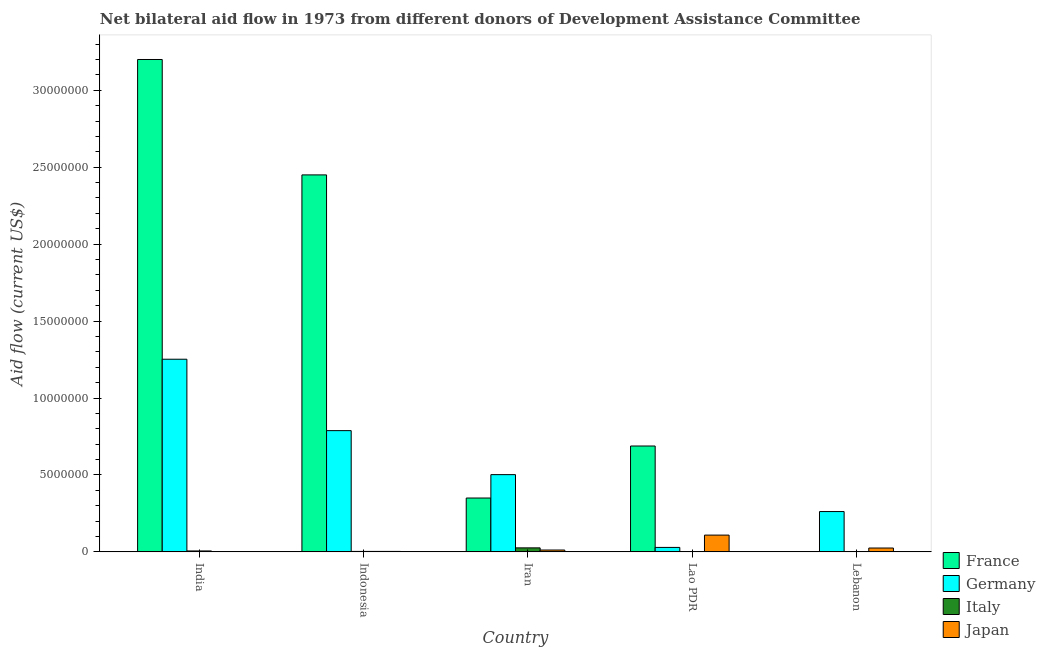Are the number of bars per tick equal to the number of legend labels?
Your response must be concise. No. How many bars are there on the 5th tick from the left?
Your answer should be compact. 3. What is the label of the 3rd group of bars from the left?
Provide a short and direct response. Iran. What is the amount of aid given by japan in Lao PDR?
Provide a short and direct response. 1.09e+06. Across all countries, what is the maximum amount of aid given by japan?
Your response must be concise. 1.09e+06. Across all countries, what is the minimum amount of aid given by italy?
Offer a very short reply. 10000. In which country was the amount of aid given by france maximum?
Your answer should be compact. India. What is the total amount of aid given by germany in the graph?
Your answer should be very brief. 2.83e+07. What is the difference between the amount of aid given by france in Iran and that in Lao PDR?
Your answer should be compact. -3.38e+06. What is the difference between the amount of aid given by germany in Lao PDR and the amount of aid given by japan in India?
Give a very brief answer. 2.80e+05. What is the difference between the amount of aid given by germany and amount of aid given by italy in India?
Keep it short and to the point. 1.25e+07. In how many countries, is the amount of aid given by japan greater than 5000000 US$?
Ensure brevity in your answer.  0. What is the ratio of the amount of aid given by germany in India to that in Iran?
Your response must be concise. 2.49. Is the amount of aid given by germany in India less than that in Lebanon?
Provide a short and direct response. No. Is the difference between the amount of aid given by italy in Iran and Lebanon greater than the difference between the amount of aid given by japan in Iran and Lebanon?
Your answer should be very brief. Yes. What is the difference between the highest and the second highest amount of aid given by germany?
Offer a very short reply. 4.64e+06. What is the difference between the highest and the lowest amount of aid given by japan?
Give a very brief answer. 1.08e+06. Is the sum of the amount of aid given by france in India and Indonesia greater than the maximum amount of aid given by italy across all countries?
Your response must be concise. Yes. Is it the case that in every country, the sum of the amount of aid given by italy and amount of aid given by germany is greater than the sum of amount of aid given by france and amount of aid given by japan?
Make the answer very short. No. Is it the case that in every country, the sum of the amount of aid given by france and amount of aid given by germany is greater than the amount of aid given by italy?
Offer a very short reply. Yes. Are all the bars in the graph horizontal?
Make the answer very short. No. How many countries are there in the graph?
Your answer should be compact. 5. Does the graph contain grids?
Your answer should be compact. No. How are the legend labels stacked?
Ensure brevity in your answer.  Vertical. What is the title of the graph?
Offer a terse response. Net bilateral aid flow in 1973 from different donors of Development Assistance Committee. Does "UNDP" appear as one of the legend labels in the graph?
Provide a succinct answer. No. What is the label or title of the X-axis?
Provide a short and direct response. Country. What is the Aid flow (current US$) of France in India?
Your response must be concise. 3.20e+07. What is the Aid flow (current US$) of Germany in India?
Your answer should be very brief. 1.25e+07. What is the Aid flow (current US$) of Japan in India?
Provide a succinct answer. 10000. What is the Aid flow (current US$) of France in Indonesia?
Your answer should be very brief. 2.45e+07. What is the Aid flow (current US$) in Germany in Indonesia?
Your answer should be very brief. 7.88e+06. What is the Aid flow (current US$) of Italy in Indonesia?
Make the answer very short. 3.00e+04. What is the Aid flow (current US$) in Japan in Indonesia?
Your answer should be very brief. 3.00e+04. What is the Aid flow (current US$) of France in Iran?
Offer a terse response. 3.50e+06. What is the Aid flow (current US$) of Germany in Iran?
Ensure brevity in your answer.  5.02e+06. What is the Aid flow (current US$) in France in Lao PDR?
Your response must be concise. 6.88e+06. What is the Aid flow (current US$) in Germany in Lao PDR?
Offer a very short reply. 2.90e+05. What is the Aid flow (current US$) in Japan in Lao PDR?
Your answer should be very brief. 1.09e+06. What is the Aid flow (current US$) of Germany in Lebanon?
Your answer should be very brief. 2.62e+06. What is the Aid flow (current US$) in Italy in Lebanon?
Keep it short and to the point. 2.00e+04. Across all countries, what is the maximum Aid flow (current US$) in France?
Offer a terse response. 3.20e+07. Across all countries, what is the maximum Aid flow (current US$) of Germany?
Give a very brief answer. 1.25e+07. Across all countries, what is the maximum Aid flow (current US$) in Japan?
Your answer should be very brief. 1.09e+06. Across all countries, what is the minimum Aid flow (current US$) of France?
Keep it short and to the point. 0. Across all countries, what is the minimum Aid flow (current US$) in Germany?
Make the answer very short. 2.90e+05. What is the total Aid flow (current US$) of France in the graph?
Offer a very short reply. 6.69e+07. What is the total Aid flow (current US$) of Germany in the graph?
Ensure brevity in your answer.  2.83e+07. What is the total Aid flow (current US$) of Japan in the graph?
Provide a succinct answer. 1.50e+06. What is the difference between the Aid flow (current US$) in France in India and that in Indonesia?
Provide a short and direct response. 7.50e+06. What is the difference between the Aid flow (current US$) in Germany in India and that in Indonesia?
Your answer should be compact. 4.64e+06. What is the difference between the Aid flow (current US$) in Italy in India and that in Indonesia?
Provide a short and direct response. 3.00e+04. What is the difference between the Aid flow (current US$) in France in India and that in Iran?
Provide a succinct answer. 2.85e+07. What is the difference between the Aid flow (current US$) of Germany in India and that in Iran?
Offer a terse response. 7.50e+06. What is the difference between the Aid flow (current US$) in Italy in India and that in Iran?
Provide a succinct answer. -2.00e+05. What is the difference between the Aid flow (current US$) of Japan in India and that in Iran?
Keep it short and to the point. -1.10e+05. What is the difference between the Aid flow (current US$) of France in India and that in Lao PDR?
Keep it short and to the point. 2.51e+07. What is the difference between the Aid flow (current US$) in Germany in India and that in Lao PDR?
Provide a succinct answer. 1.22e+07. What is the difference between the Aid flow (current US$) of Japan in India and that in Lao PDR?
Offer a terse response. -1.08e+06. What is the difference between the Aid flow (current US$) in Germany in India and that in Lebanon?
Keep it short and to the point. 9.90e+06. What is the difference between the Aid flow (current US$) of Italy in India and that in Lebanon?
Ensure brevity in your answer.  4.00e+04. What is the difference between the Aid flow (current US$) in France in Indonesia and that in Iran?
Provide a short and direct response. 2.10e+07. What is the difference between the Aid flow (current US$) in Germany in Indonesia and that in Iran?
Your response must be concise. 2.86e+06. What is the difference between the Aid flow (current US$) in Italy in Indonesia and that in Iran?
Provide a succinct answer. -2.30e+05. What is the difference between the Aid flow (current US$) of Japan in Indonesia and that in Iran?
Your response must be concise. -9.00e+04. What is the difference between the Aid flow (current US$) of France in Indonesia and that in Lao PDR?
Offer a very short reply. 1.76e+07. What is the difference between the Aid flow (current US$) in Germany in Indonesia and that in Lao PDR?
Your response must be concise. 7.59e+06. What is the difference between the Aid flow (current US$) in Italy in Indonesia and that in Lao PDR?
Offer a very short reply. 2.00e+04. What is the difference between the Aid flow (current US$) of Japan in Indonesia and that in Lao PDR?
Offer a very short reply. -1.06e+06. What is the difference between the Aid flow (current US$) in Germany in Indonesia and that in Lebanon?
Give a very brief answer. 5.26e+06. What is the difference between the Aid flow (current US$) in Japan in Indonesia and that in Lebanon?
Ensure brevity in your answer.  -2.20e+05. What is the difference between the Aid flow (current US$) in France in Iran and that in Lao PDR?
Provide a short and direct response. -3.38e+06. What is the difference between the Aid flow (current US$) of Germany in Iran and that in Lao PDR?
Your answer should be compact. 4.73e+06. What is the difference between the Aid flow (current US$) of Italy in Iran and that in Lao PDR?
Give a very brief answer. 2.50e+05. What is the difference between the Aid flow (current US$) of Japan in Iran and that in Lao PDR?
Provide a short and direct response. -9.70e+05. What is the difference between the Aid flow (current US$) in Germany in Iran and that in Lebanon?
Keep it short and to the point. 2.40e+06. What is the difference between the Aid flow (current US$) in Japan in Iran and that in Lebanon?
Provide a succinct answer. -1.30e+05. What is the difference between the Aid flow (current US$) of Germany in Lao PDR and that in Lebanon?
Make the answer very short. -2.33e+06. What is the difference between the Aid flow (current US$) of Italy in Lao PDR and that in Lebanon?
Your answer should be compact. -10000. What is the difference between the Aid flow (current US$) of Japan in Lao PDR and that in Lebanon?
Offer a terse response. 8.40e+05. What is the difference between the Aid flow (current US$) in France in India and the Aid flow (current US$) in Germany in Indonesia?
Offer a terse response. 2.41e+07. What is the difference between the Aid flow (current US$) of France in India and the Aid flow (current US$) of Italy in Indonesia?
Provide a succinct answer. 3.20e+07. What is the difference between the Aid flow (current US$) of France in India and the Aid flow (current US$) of Japan in Indonesia?
Your response must be concise. 3.20e+07. What is the difference between the Aid flow (current US$) of Germany in India and the Aid flow (current US$) of Italy in Indonesia?
Make the answer very short. 1.25e+07. What is the difference between the Aid flow (current US$) of Germany in India and the Aid flow (current US$) of Japan in Indonesia?
Ensure brevity in your answer.  1.25e+07. What is the difference between the Aid flow (current US$) in France in India and the Aid flow (current US$) in Germany in Iran?
Provide a succinct answer. 2.70e+07. What is the difference between the Aid flow (current US$) in France in India and the Aid flow (current US$) in Italy in Iran?
Keep it short and to the point. 3.17e+07. What is the difference between the Aid flow (current US$) in France in India and the Aid flow (current US$) in Japan in Iran?
Give a very brief answer. 3.19e+07. What is the difference between the Aid flow (current US$) in Germany in India and the Aid flow (current US$) in Italy in Iran?
Keep it short and to the point. 1.23e+07. What is the difference between the Aid flow (current US$) in Germany in India and the Aid flow (current US$) in Japan in Iran?
Offer a very short reply. 1.24e+07. What is the difference between the Aid flow (current US$) in France in India and the Aid flow (current US$) in Germany in Lao PDR?
Your response must be concise. 3.17e+07. What is the difference between the Aid flow (current US$) of France in India and the Aid flow (current US$) of Italy in Lao PDR?
Provide a succinct answer. 3.20e+07. What is the difference between the Aid flow (current US$) of France in India and the Aid flow (current US$) of Japan in Lao PDR?
Offer a terse response. 3.09e+07. What is the difference between the Aid flow (current US$) of Germany in India and the Aid flow (current US$) of Italy in Lao PDR?
Keep it short and to the point. 1.25e+07. What is the difference between the Aid flow (current US$) of Germany in India and the Aid flow (current US$) of Japan in Lao PDR?
Your response must be concise. 1.14e+07. What is the difference between the Aid flow (current US$) in Italy in India and the Aid flow (current US$) in Japan in Lao PDR?
Your response must be concise. -1.03e+06. What is the difference between the Aid flow (current US$) in France in India and the Aid flow (current US$) in Germany in Lebanon?
Offer a very short reply. 2.94e+07. What is the difference between the Aid flow (current US$) of France in India and the Aid flow (current US$) of Italy in Lebanon?
Make the answer very short. 3.20e+07. What is the difference between the Aid flow (current US$) of France in India and the Aid flow (current US$) of Japan in Lebanon?
Your answer should be very brief. 3.18e+07. What is the difference between the Aid flow (current US$) of Germany in India and the Aid flow (current US$) of Italy in Lebanon?
Keep it short and to the point. 1.25e+07. What is the difference between the Aid flow (current US$) of Germany in India and the Aid flow (current US$) of Japan in Lebanon?
Give a very brief answer. 1.23e+07. What is the difference between the Aid flow (current US$) in France in Indonesia and the Aid flow (current US$) in Germany in Iran?
Your response must be concise. 1.95e+07. What is the difference between the Aid flow (current US$) of France in Indonesia and the Aid flow (current US$) of Italy in Iran?
Your answer should be very brief. 2.42e+07. What is the difference between the Aid flow (current US$) in France in Indonesia and the Aid flow (current US$) in Japan in Iran?
Keep it short and to the point. 2.44e+07. What is the difference between the Aid flow (current US$) in Germany in Indonesia and the Aid flow (current US$) in Italy in Iran?
Provide a short and direct response. 7.62e+06. What is the difference between the Aid flow (current US$) in Germany in Indonesia and the Aid flow (current US$) in Japan in Iran?
Provide a short and direct response. 7.76e+06. What is the difference between the Aid flow (current US$) of Italy in Indonesia and the Aid flow (current US$) of Japan in Iran?
Offer a terse response. -9.00e+04. What is the difference between the Aid flow (current US$) of France in Indonesia and the Aid flow (current US$) of Germany in Lao PDR?
Give a very brief answer. 2.42e+07. What is the difference between the Aid flow (current US$) in France in Indonesia and the Aid flow (current US$) in Italy in Lao PDR?
Offer a very short reply. 2.45e+07. What is the difference between the Aid flow (current US$) in France in Indonesia and the Aid flow (current US$) in Japan in Lao PDR?
Keep it short and to the point. 2.34e+07. What is the difference between the Aid flow (current US$) of Germany in Indonesia and the Aid flow (current US$) of Italy in Lao PDR?
Make the answer very short. 7.87e+06. What is the difference between the Aid flow (current US$) of Germany in Indonesia and the Aid flow (current US$) of Japan in Lao PDR?
Provide a short and direct response. 6.79e+06. What is the difference between the Aid flow (current US$) in Italy in Indonesia and the Aid flow (current US$) in Japan in Lao PDR?
Offer a very short reply. -1.06e+06. What is the difference between the Aid flow (current US$) of France in Indonesia and the Aid flow (current US$) of Germany in Lebanon?
Your answer should be very brief. 2.19e+07. What is the difference between the Aid flow (current US$) in France in Indonesia and the Aid flow (current US$) in Italy in Lebanon?
Give a very brief answer. 2.45e+07. What is the difference between the Aid flow (current US$) in France in Indonesia and the Aid flow (current US$) in Japan in Lebanon?
Your response must be concise. 2.42e+07. What is the difference between the Aid flow (current US$) in Germany in Indonesia and the Aid flow (current US$) in Italy in Lebanon?
Keep it short and to the point. 7.86e+06. What is the difference between the Aid flow (current US$) in Germany in Indonesia and the Aid flow (current US$) in Japan in Lebanon?
Your answer should be compact. 7.63e+06. What is the difference between the Aid flow (current US$) of France in Iran and the Aid flow (current US$) of Germany in Lao PDR?
Give a very brief answer. 3.21e+06. What is the difference between the Aid flow (current US$) in France in Iran and the Aid flow (current US$) in Italy in Lao PDR?
Your response must be concise. 3.49e+06. What is the difference between the Aid flow (current US$) in France in Iran and the Aid flow (current US$) in Japan in Lao PDR?
Give a very brief answer. 2.41e+06. What is the difference between the Aid flow (current US$) in Germany in Iran and the Aid flow (current US$) in Italy in Lao PDR?
Keep it short and to the point. 5.01e+06. What is the difference between the Aid flow (current US$) of Germany in Iran and the Aid flow (current US$) of Japan in Lao PDR?
Give a very brief answer. 3.93e+06. What is the difference between the Aid flow (current US$) in Italy in Iran and the Aid flow (current US$) in Japan in Lao PDR?
Ensure brevity in your answer.  -8.30e+05. What is the difference between the Aid flow (current US$) of France in Iran and the Aid flow (current US$) of Germany in Lebanon?
Give a very brief answer. 8.80e+05. What is the difference between the Aid flow (current US$) in France in Iran and the Aid flow (current US$) in Italy in Lebanon?
Give a very brief answer. 3.48e+06. What is the difference between the Aid flow (current US$) in France in Iran and the Aid flow (current US$) in Japan in Lebanon?
Give a very brief answer. 3.25e+06. What is the difference between the Aid flow (current US$) of Germany in Iran and the Aid flow (current US$) of Italy in Lebanon?
Your response must be concise. 5.00e+06. What is the difference between the Aid flow (current US$) in Germany in Iran and the Aid flow (current US$) in Japan in Lebanon?
Keep it short and to the point. 4.77e+06. What is the difference between the Aid flow (current US$) of Italy in Iran and the Aid flow (current US$) of Japan in Lebanon?
Ensure brevity in your answer.  10000. What is the difference between the Aid flow (current US$) in France in Lao PDR and the Aid flow (current US$) in Germany in Lebanon?
Offer a terse response. 4.26e+06. What is the difference between the Aid flow (current US$) of France in Lao PDR and the Aid flow (current US$) of Italy in Lebanon?
Your answer should be very brief. 6.86e+06. What is the difference between the Aid flow (current US$) in France in Lao PDR and the Aid flow (current US$) in Japan in Lebanon?
Offer a terse response. 6.63e+06. What is the average Aid flow (current US$) in France per country?
Give a very brief answer. 1.34e+07. What is the average Aid flow (current US$) in Germany per country?
Provide a succinct answer. 5.67e+06. What is the average Aid flow (current US$) of Italy per country?
Your answer should be compact. 7.60e+04. What is the difference between the Aid flow (current US$) in France and Aid flow (current US$) in Germany in India?
Give a very brief answer. 1.95e+07. What is the difference between the Aid flow (current US$) of France and Aid flow (current US$) of Italy in India?
Give a very brief answer. 3.19e+07. What is the difference between the Aid flow (current US$) in France and Aid flow (current US$) in Japan in India?
Your response must be concise. 3.20e+07. What is the difference between the Aid flow (current US$) of Germany and Aid flow (current US$) of Italy in India?
Ensure brevity in your answer.  1.25e+07. What is the difference between the Aid flow (current US$) of Germany and Aid flow (current US$) of Japan in India?
Keep it short and to the point. 1.25e+07. What is the difference between the Aid flow (current US$) of France and Aid flow (current US$) of Germany in Indonesia?
Ensure brevity in your answer.  1.66e+07. What is the difference between the Aid flow (current US$) in France and Aid flow (current US$) in Italy in Indonesia?
Your answer should be compact. 2.45e+07. What is the difference between the Aid flow (current US$) of France and Aid flow (current US$) of Japan in Indonesia?
Ensure brevity in your answer.  2.45e+07. What is the difference between the Aid flow (current US$) of Germany and Aid flow (current US$) of Italy in Indonesia?
Your response must be concise. 7.85e+06. What is the difference between the Aid flow (current US$) in Germany and Aid flow (current US$) in Japan in Indonesia?
Give a very brief answer. 7.85e+06. What is the difference between the Aid flow (current US$) of France and Aid flow (current US$) of Germany in Iran?
Ensure brevity in your answer.  -1.52e+06. What is the difference between the Aid flow (current US$) of France and Aid flow (current US$) of Italy in Iran?
Ensure brevity in your answer.  3.24e+06. What is the difference between the Aid flow (current US$) of France and Aid flow (current US$) of Japan in Iran?
Your response must be concise. 3.38e+06. What is the difference between the Aid flow (current US$) in Germany and Aid flow (current US$) in Italy in Iran?
Provide a succinct answer. 4.76e+06. What is the difference between the Aid flow (current US$) of Germany and Aid flow (current US$) of Japan in Iran?
Your answer should be very brief. 4.90e+06. What is the difference between the Aid flow (current US$) in Italy and Aid flow (current US$) in Japan in Iran?
Make the answer very short. 1.40e+05. What is the difference between the Aid flow (current US$) of France and Aid flow (current US$) of Germany in Lao PDR?
Your answer should be very brief. 6.59e+06. What is the difference between the Aid flow (current US$) in France and Aid flow (current US$) in Italy in Lao PDR?
Ensure brevity in your answer.  6.87e+06. What is the difference between the Aid flow (current US$) of France and Aid flow (current US$) of Japan in Lao PDR?
Your answer should be compact. 5.79e+06. What is the difference between the Aid flow (current US$) in Germany and Aid flow (current US$) in Japan in Lao PDR?
Keep it short and to the point. -8.00e+05. What is the difference between the Aid flow (current US$) of Italy and Aid flow (current US$) of Japan in Lao PDR?
Your answer should be very brief. -1.08e+06. What is the difference between the Aid flow (current US$) in Germany and Aid flow (current US$) in Italy in Lebanon?
Offer a terse response. 2.60e+06. What is the difference between the Aid flow (current US$) of Germany and Aid flow (current US$) of Japan in Lebanon?
Your response must be concise. 2.37e+06. What is the difference between the Aid flow (current US$) in Italy and Aid flow (current US$) in Japan in Lebanon?
Provide a succinct answer. -2.30e+05. What is the ratio of the Aid flow (current US$) of France in India to that in Indonesia?
Give a very brief answer. 1.31. What is the ratio of the Aid flow (current US$) in Germany in India to that in Indonesia?
Provide a succinct answer. 1.59. What is the ratio of the Aid flow (current US$) of France in India to that in Iran?
Provide a succinct answer. 9.14. What is the ratio of the Aid flow (current US$) in Germany in India to that in Iran?
Offer a terse response. 2.49. What is the ratio of the Aid flow (current US$) in Italy in India to that in Iran?
Your answer should be very brief. 0.23. What is the ratio of the Aid flow (current US$) in Japan in India to that in Iran?
Make the answer very short. 0.08. What is the ratio of the Aid flow (current US$) in France in India to that in Lao PDR?
Provide a succinct answer. 4.65. What is the ratio of the Aid flow (current US$) in Germany in India to that in Lao PDR?
Offer a terse response. 43.17. What is the ratio of the Aid flow (current US$) of Italy in India to that in Lao PDR?
Ensure brevity in your answer.  6. What is the ratio of the Aid flow (current US$) in Japan in India to that in Lao PDR?
Offer a very short reply. 0.01. What is the ratio of the Aid flow (current US$) of Germany in India to that in Lebanon?
Provide a short and direct response. 4.78. What is the ratio of the Aid flow (current US$) of Italy in India to that in Lebanon?
Keep it short and to the point. 3. What is the ratio of the Aid flow (current US$) of Germany in Indonesia to that in Iran?
Keep it short and to the point. 1.57. What is the ratio of the Aid flow (current US$) of Italy in Indonesia to that in Iran?
Make the answer very short. 0.12. What is the ratio of the Aid flow (current US$) in Japan in Indonesia to that in Iran?
Your answer should be compact. 0.25. What is the ratio of the Aid flow (current US$) in France in Indonesia to that in Lao PDR?
Offer a very short reply. 3.56. What is the ratio of the Aid flow (current US$) of Germany in Indonesia to that in Lao PDR?
Offer a terse response. 27.17. What is the ratio of the Aid flow (current US$) in Japan in Indonesia to that in Lao PDR?
Your answer should be very brief. 0.03. What is the ratio of the Aid flow (current US$) in Germany in Indonesia to that in Lebanon?
Provide a succinct answer. 3.01. What is the ratio of the Aid flow (current US$) in Japan in Indonesia to that in Lebanon?
Keep it short and to the point. 0.12. What is the ratio of the Aid flow (current US$) in France in Iran to that in Lao PDR?
Your answer should be very brief. 0.51. What is the ratio of the Aid flow (current US$) of Germany in Iran to that in Lao PDR?
Provide a succinct answer. 17.31. What is the ratio of the Aid flow (current US$) of Italy in Iran to that in Lao PDR?
Your response must be concise. 26. What is the ratio of the Aid flow (current US$) of Japan in Iran to that in Lao PDR?
Provide a short and direct response. 0.11. What is the ratio of the Aid flow (current US$) of Germany in Iran to that in Lebanon?
Give a very brief answer. 1.92. What is the ratio of the Aid flow (current US$) in Japan in Iran to that in Lebanon?
Make the answer very short. 0.48. What is the ratio of the Aid flow (current US$) of Germany in Lao PDR to that in Lebanon?
Provide a succinct answer. 0.11. What is the ratio of the Aid flow (current US$) in Japan in Lao PDR to that in Lebanon?
Your answer should be very brief. 4.36. What is the difference between the highest and the second highest Aid flow (current US$) of France?
Offer a terse response. 7.50e+06. What is the difference between the highest and the second highest Aid flow (current US$) of Germany?
Ensure brevity in your answer.  4.64e+06. What is the difference between the highest and the second highest Aid flow (current US$) of Japan?
Your answer should be compact. 8.40e+05. What is the difference between the highest and the lowest Aid flow (current US$) in France?
Your answer should be very brief. 3.20e+07. What is the difference between the highest and the lowest Aid flow (current US$) in Germany?
Keep it short and to the point. 1.22e+07. What is the difference between the highest and the lowest Aid flow (current US$) of Japan?
Give a very brief answer. 1.08e+06. 